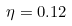<formula> <loc_0><loc_0><loc_500><loc_500>\eta = 0 . 1 2</formula> 